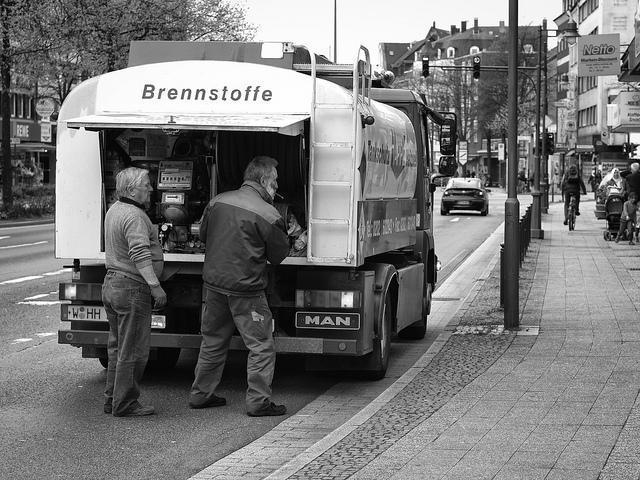How many people are there?
Give a very brief answer. 2. How many rolls of toilet paper is there?
Give a very brief answer. 0. 